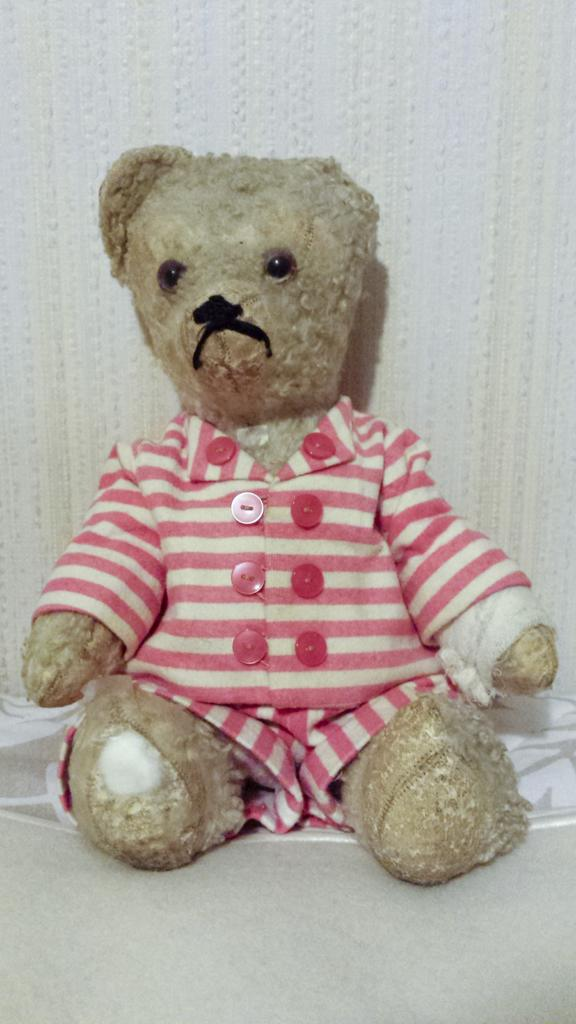What is the main object in the image? There is a toy in the image. What is the toy placed on? The toy is on a white surface. What can be observed about the toy's appearance? The toy has a dress. What colors are present in the toy's dress? The dress is white and pink in color. What is the color of the background in the image? The background of the image is white. What is the price of the curtain in the image? There is no curtain present in the image, so it is not possible to determine its price. 